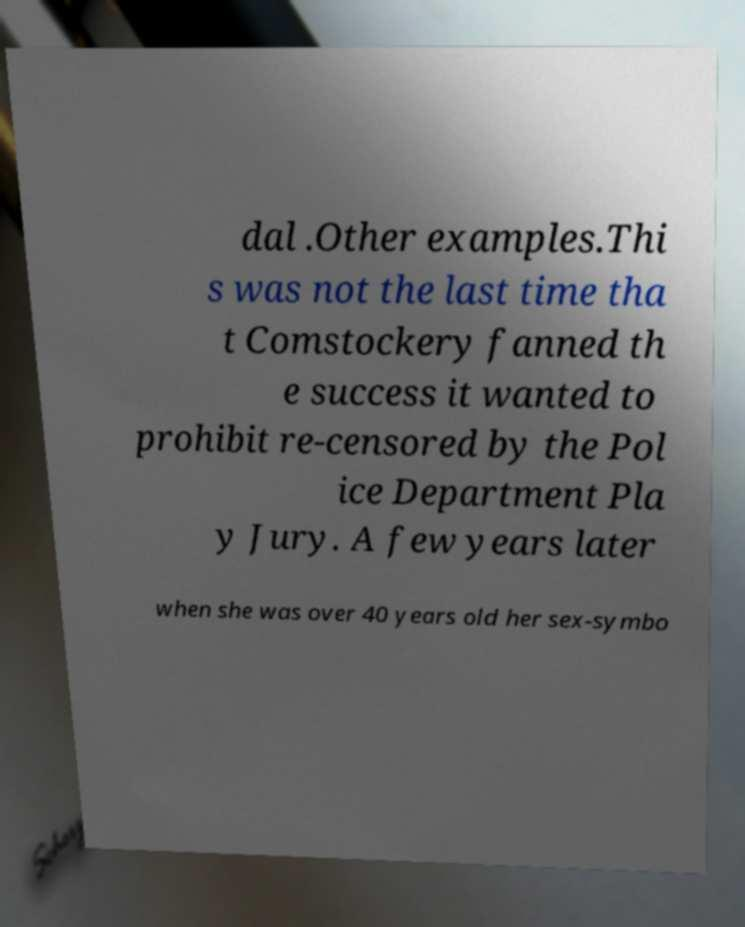There's text embedded in this image that I need extracted. Can you transcribe it verbatim? dal .Other examples.Thi s was not the last time tha t Comstockery fanned th e success it wanted to prohibit re-censored by the Pol ice Department Pla y Jury. A few years later when she was over 40 years old her sex-symbo 